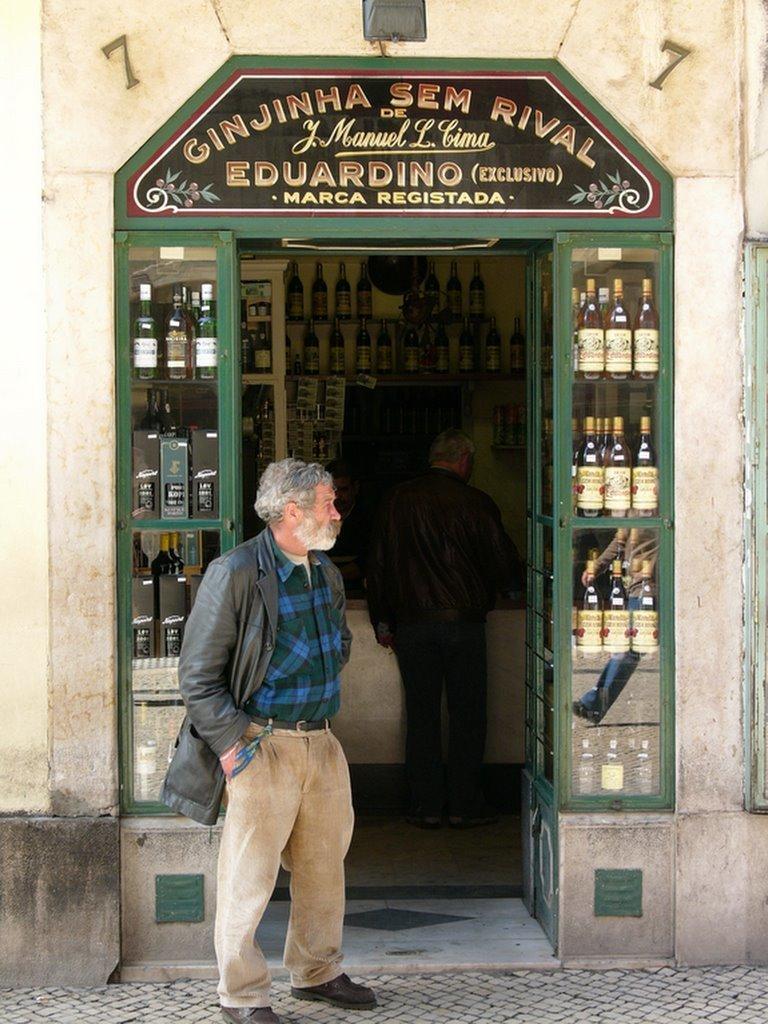Can you describe this image briefly? In this image I can see a person standing in front of a building and wearing a coat. There are glass bottles in the shelves and a board at the top. A person is standing inside a building and there are glass bottles in the shelves. 